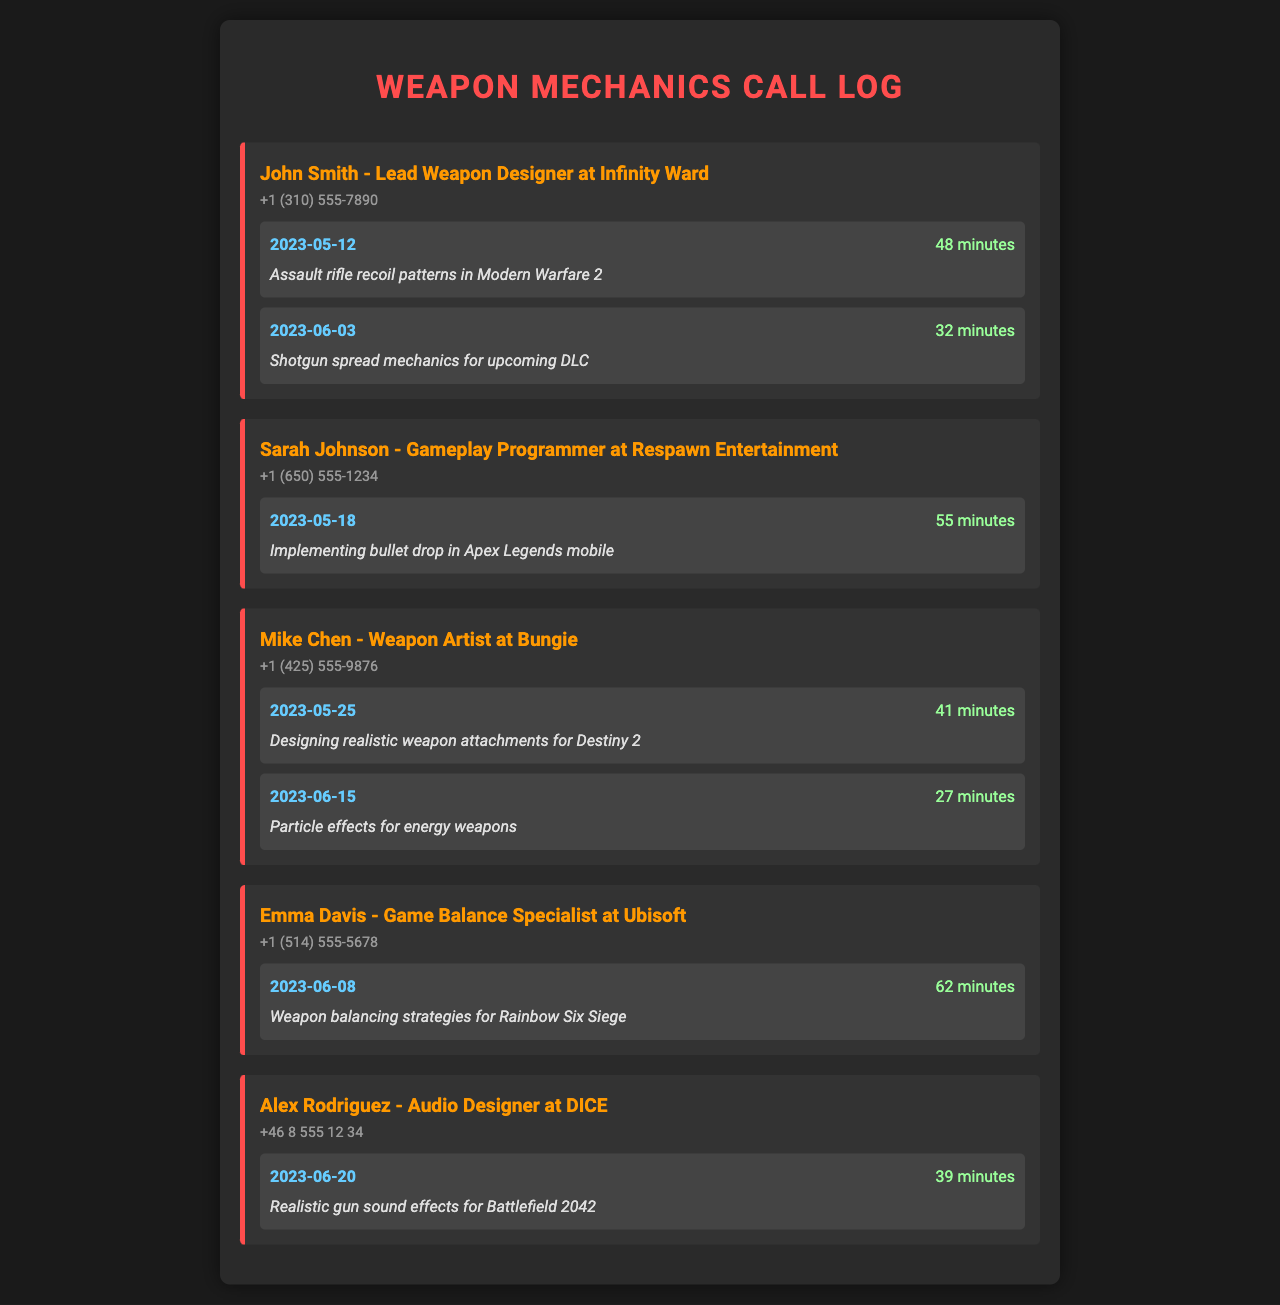What is the date of the call with John Smith? The date of the call is specifically mentioned in the document, which is 2023-05-12.
Answer: 2023-05-12 How long did the call with Sarah Johnson last? The document specifies that the duration of the call with Sarah Johnson is 55 minutes.
Answer: 55 minutes Which weapon's mechanics was discussed during the call with Emma Davis? The document mentions that the topic of the call with Emma Davis was weapon balancing strategies for Rainbow Six Siege.
Answer: Rainbow Six Siege How many calls did Mike Chen have listed? By counting the calls associated with Mike Chen in the document, we see there are two calls listed.
Answer: 2 Who is the Lead Weapon Designer at Infinity Ward? The document identifies John Smith as the Lead Weapon Designer at Infinity Ward.
Answer: John Smith What was the topic of the call on June 20, 2023? The document states that the topic of the call on that date was realistic gun sound effects for Battlefield 2042.
Answer: Realistic gun sound effects for Battlefield 2042 Which developer discussed the implementation of bullet drop? The document lists Sarah Johnson as the developer who discussed implementing bullet drop.
Answer: Sarah Johnson What is the phone number for Alex Rodriguez? The document provides the contact number for Alex Rodriguez as +46 8 555 12 34.
Answer: +46 8 555 12 34 